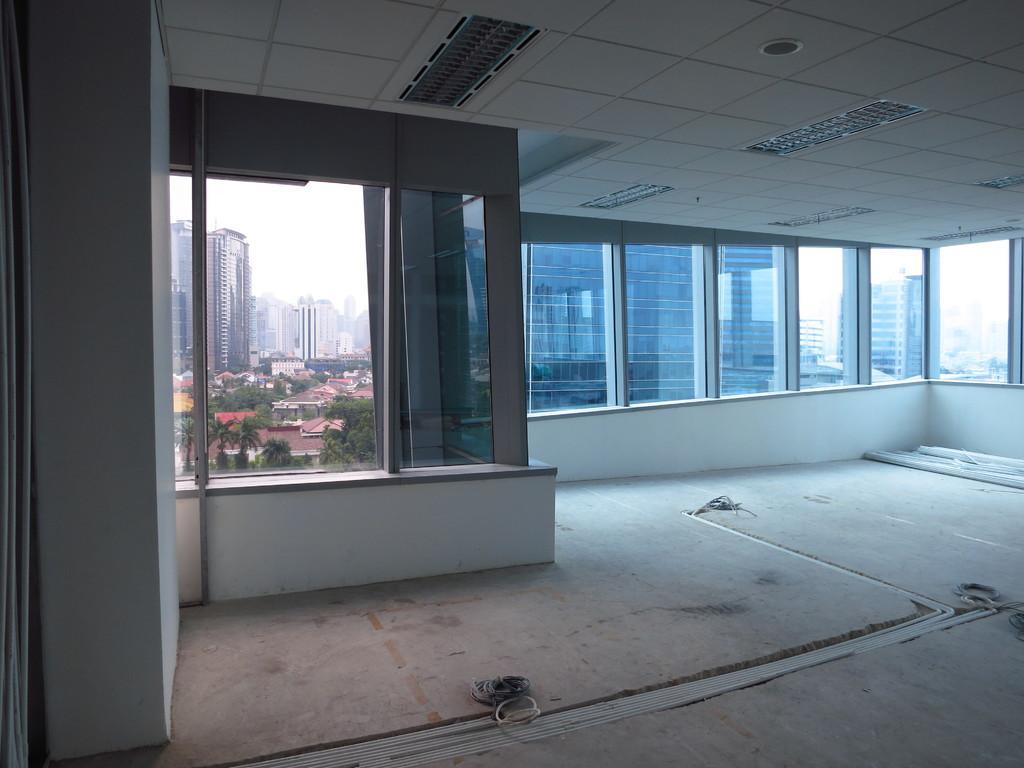How would you summarize this image in a sentence or two? In this picture we can see inside view of room. Behind we can see glass windows and some trees and buildings. On the top there are some lights on the ceiling. 